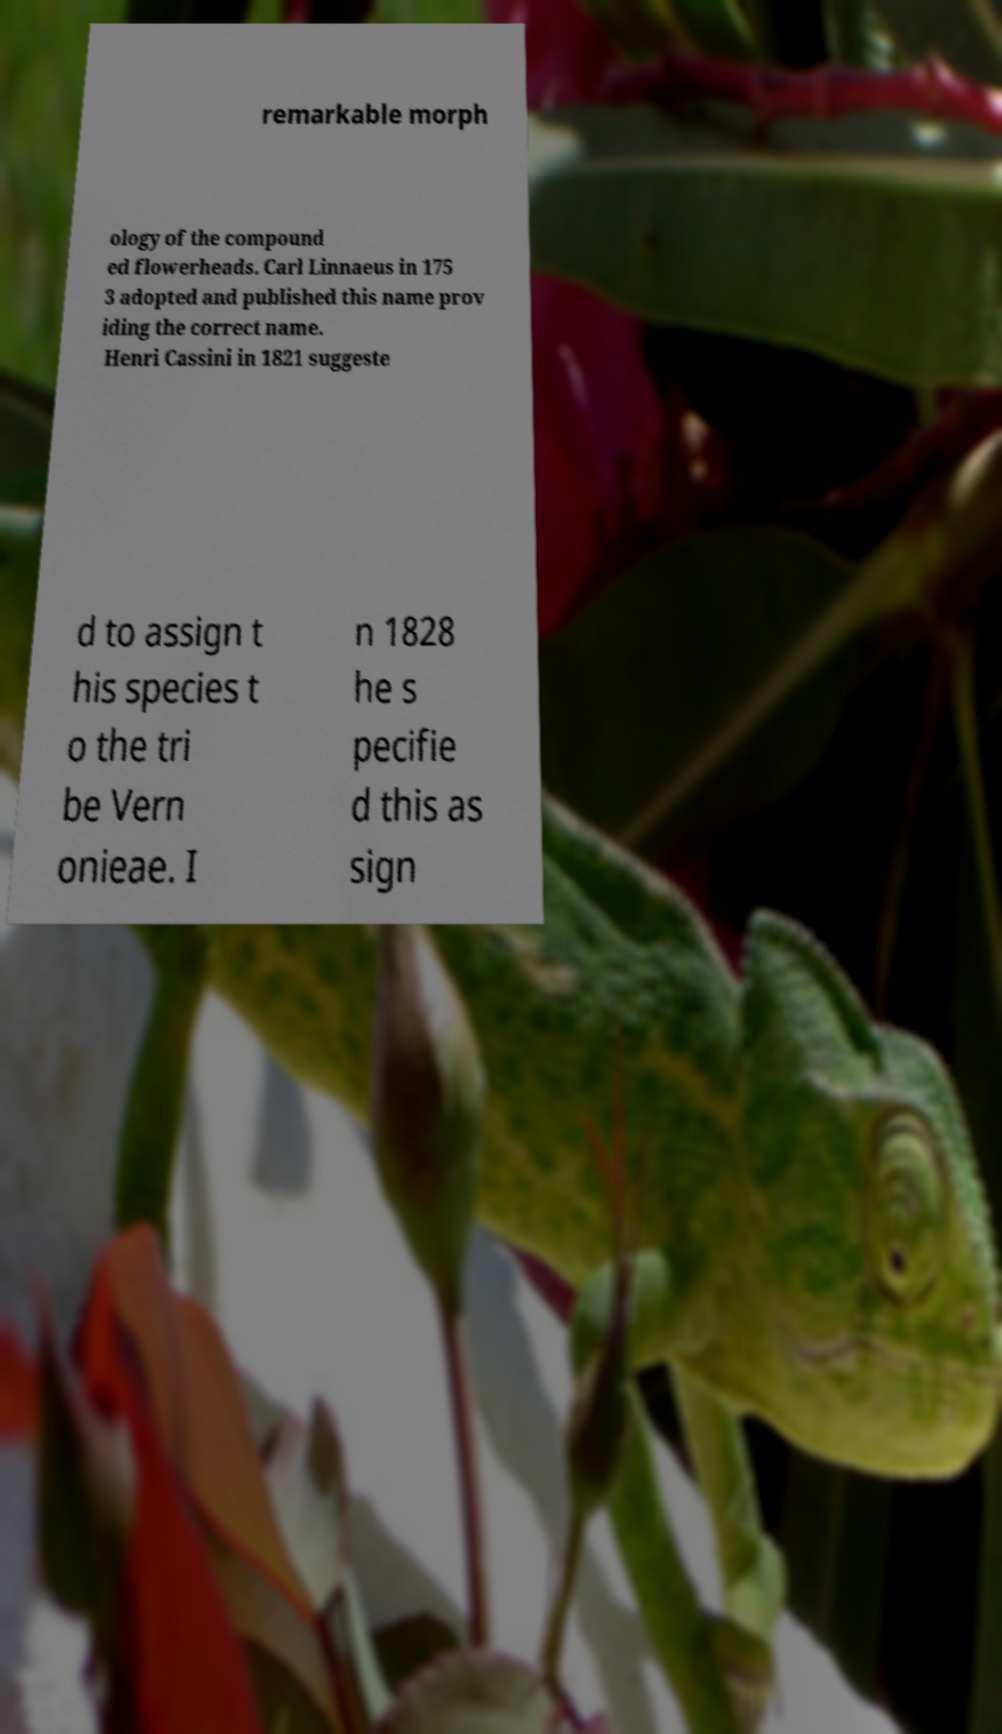For documentation purposes, I need the text within this image transcribed. Could you provide that? remarkable morph ology of the compound ed flowerheads. Carl Linnaeus in 175 3 adopted and published this name prov iding the correct name. Henri Cassini in 1821 suggeste d to assign t his species t o the tri be Vern onieae. I n 1828 he s pecifie d this as sign 